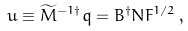<formula> <loc_0><loc_0><loc_500><loc_500>u \equiv \widetilde { M } ^ { - 1 \dagger } q = B ^ { \dagger } N F ^ { 1 / 2 } \, ,</formula> 